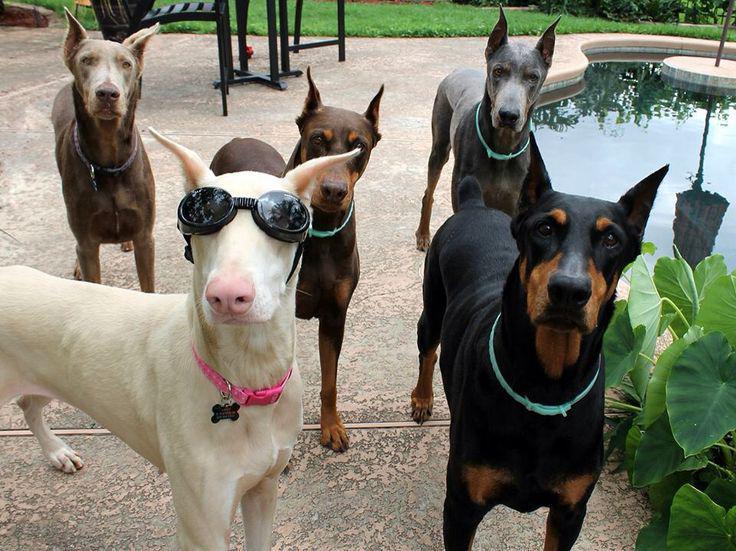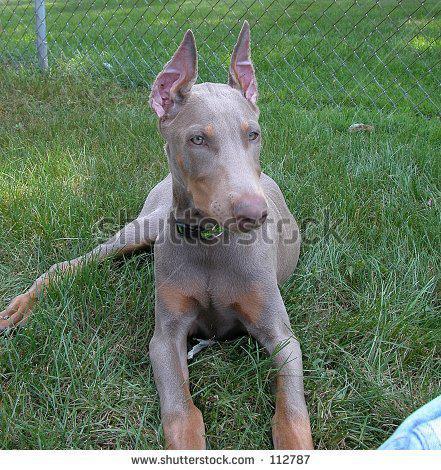The first image is the image on the left, the second image is the image on the right. Considering the images on both sides, is "One image includes a non-standing doberman wearing a chain collar, and the other image shows at least two dogs standing side-by-side on the grass." valid? Answer yes or no. No. The first image is the image on the left, the second image is the image on the right. Analyze the images presented: Is the assertion "The right image contains exactly two dogs." valid? Answer yes or no. No. 